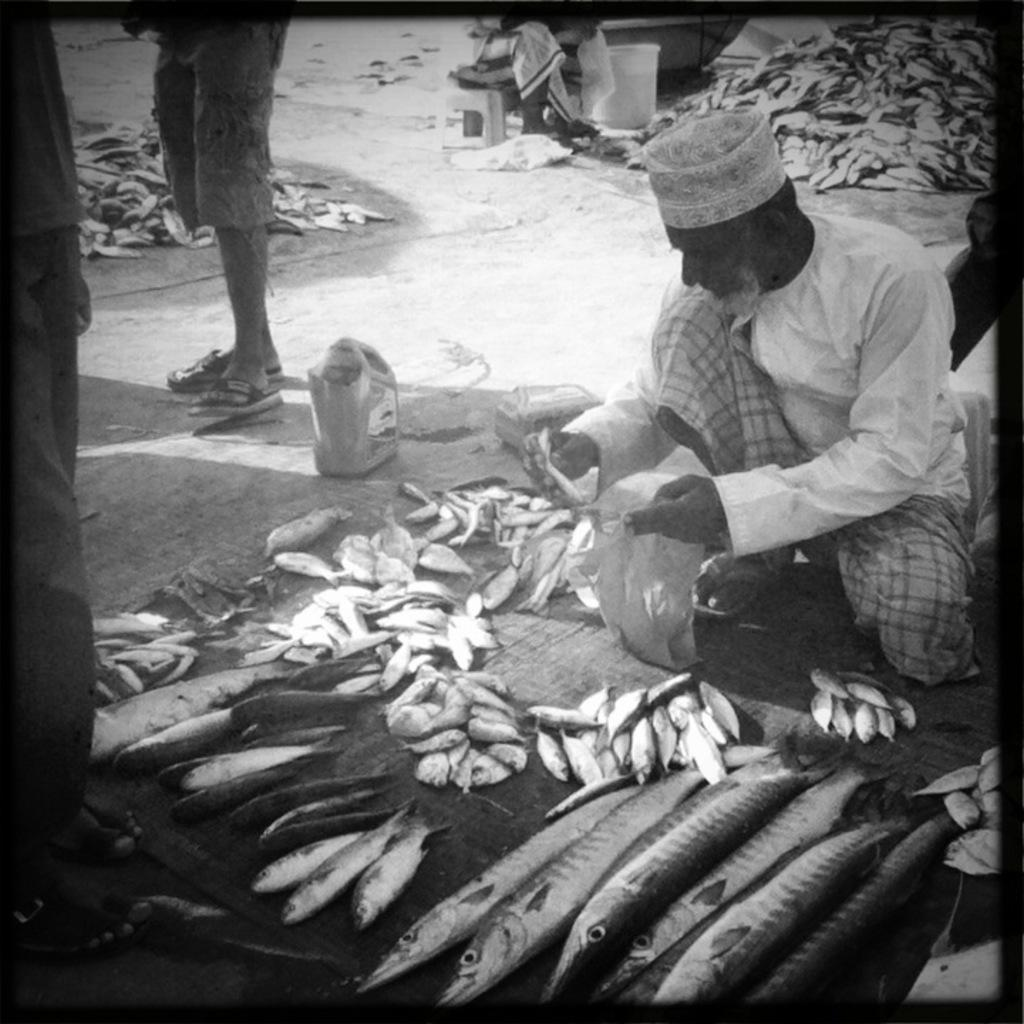What type of animals can be seen in the image? There is a group of fish in the image. What else is present in the image besides the fish? There are people on the ground in the image. Can you describe any other objects or elements in the image? There are unspecified objects in the image. What type of cabbage can be seen floating in the water with the fish in the image? There is no cabbage present in the image; it only features a group of fish and people on the ground. 